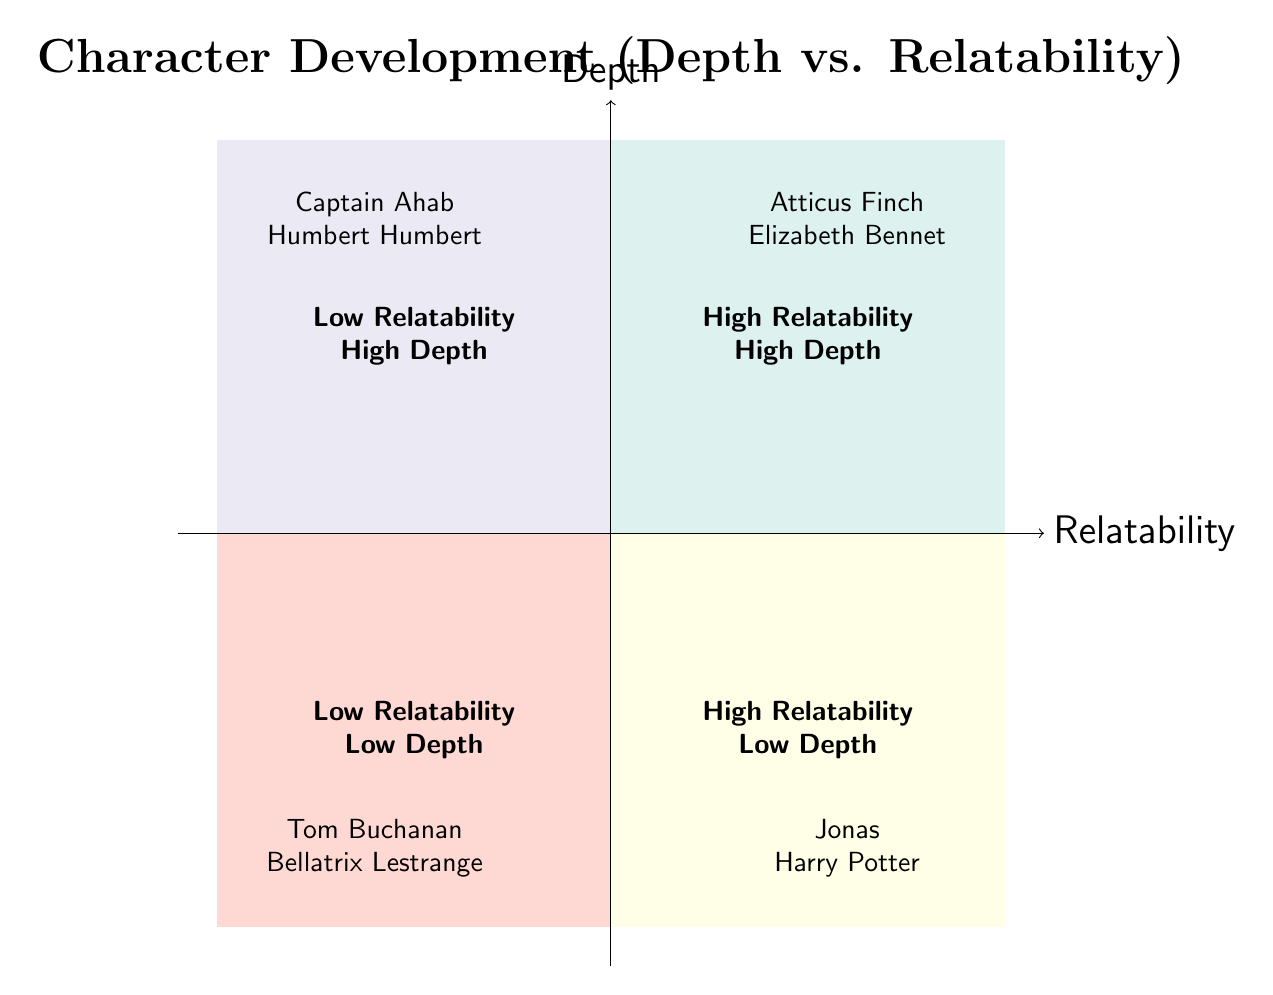What character is located in the High Relatability and High Depth quadrant? The diagram indicates that Atticus Finch and Elizabeth Bennet are examples of characters in the High Relatability and High Depth quadrant, thus answering the question directly.
Answer: Atticus Finch, Elizabeth Bennet Which quadrant contains characters with Low Relatability and High Depth? The diagram clearly states that Captain Ahab and Humbert Humbert are examples found in the Low Relatability and High Depth quadrant, leading to this answer.
Answer: Captain Ahab, Humbert Humbert How many examples are provided for characters in the Low Relatability and Low Depth quadrant? By examining the Low Relatability and Low Depth quadrant in the diagram, I can see two examples given, which answers the question directly.
Answer: 2 What is described as the characteristic of the Low Relatability and High Depth quadrant? The diagram describes characters in the Low Relatability and High Depth quadrant as being deeply developed but not easily relatable, which is the concise answer.
Answer: Deeply developed but not easily relatable Which characters are described as being High Relatability and Low Depth? Referring to the specific section on High Relatability and Low Depth in the diagram, the characters Jonas and Harry Potter are mentioned as examples.
Answer: Jonas, Harry Potter What does the High Relatability and High Depth quadrant signify about its characters? The diagram states that characters in this quadrant are both deeply developed and highly relatable to the audience, clearly defining their characteristics.
Answer: Deeply developed and highly relatable In which quadrant would you classify Tom Buchanan? By checking the quadrant labels, it is clear that Tom Buchanan is listed in the Low Relatability and Low Depth quadrant, which directly answers the question.
Answer: Low Relatability and Low Depth Why might a character like Elizabeth Bennet be seen as highly relatable? The diagram in the High Relatability and High Depth quadrant suggests that characters like Elizabeth Bennet exhibit traits or situations that resonate well with audiences, enhancing her relatability.
Answer: Traits that resonate with audiences Which quadrant features characters that lack substantial depth? The diagram indicates that characters in the High Relatability and Low Depth quadrant lack substantial depth, which is the answer needed.
Answer: High Relatability and Low Depth 